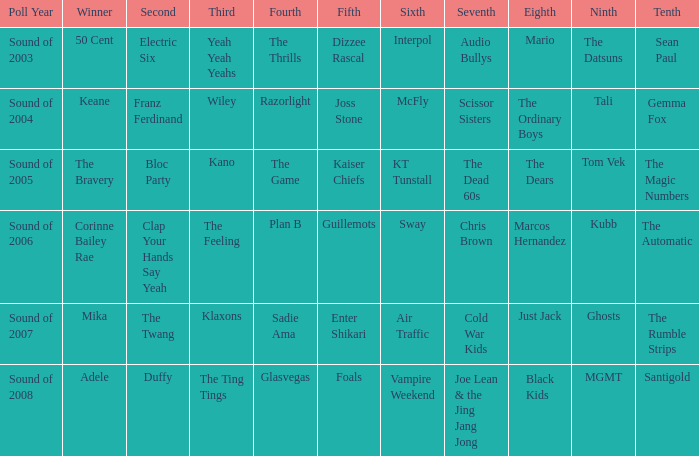On how many occasions did plan b rank 4th? 1.0. 